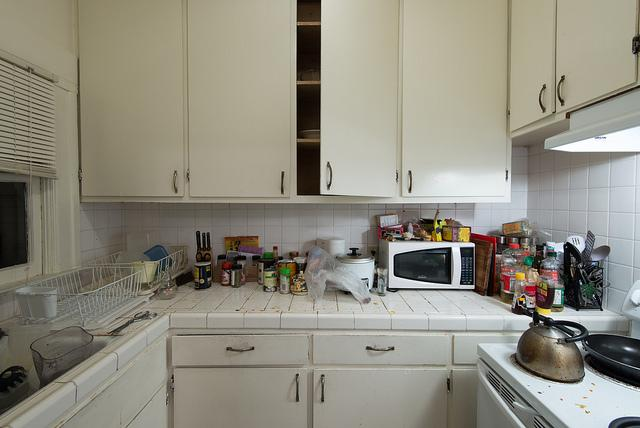Why is there a dish drainer on the counter? Please explain your reasoning. no dishwasher. There is no machine to wash dishes so they wash by hand using the dish drainer. 